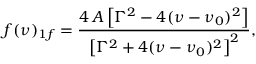<formula> <loc_0><loc_0><loc_500><loc_500>f ( \nu ) _ { 1 f } = \frac { 4 \, A \left [ \Gamma ^ { 2 } - 4 ( \nu - \nu _ { 0 } ) ^ { 2 } \right ] } { \left [ \Gamma ^ { 2 } + 4 ( \nu - \nu _ { 0 } ) ^ { 2 } \right ] ^ { 2 } } ,</formula> 